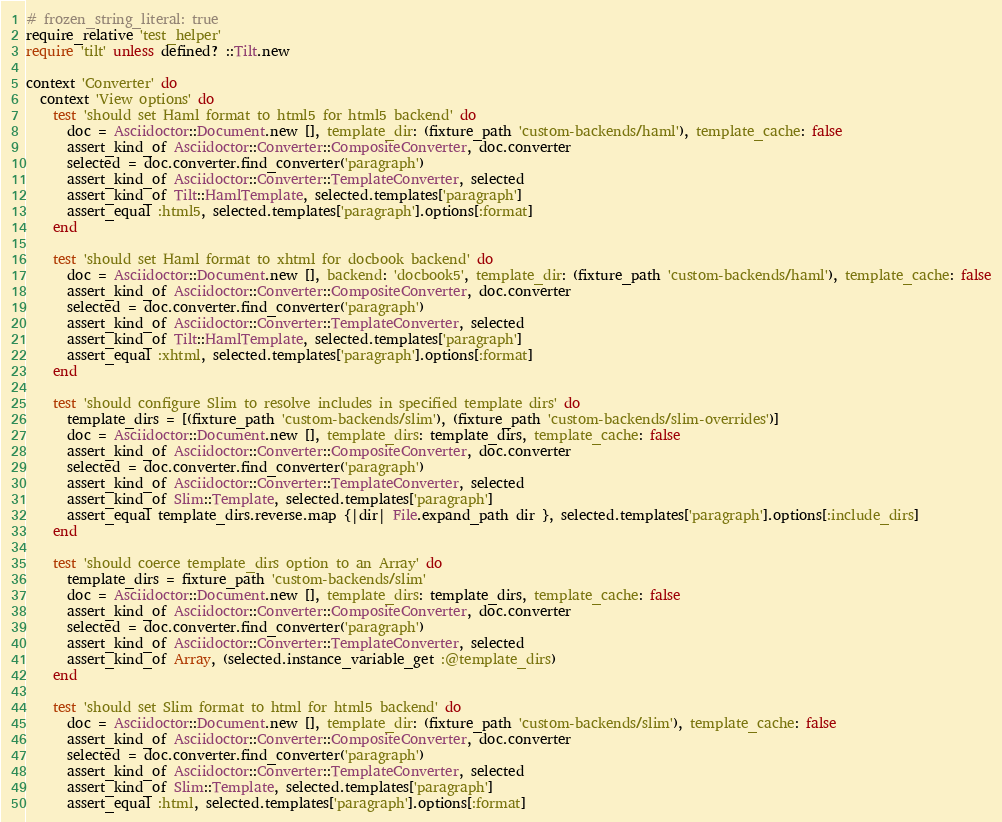Convert code to text. <code><loc_0><loc_0><loc_500><loc_500><_Ruby_># frozen_string_literal: true
require_relative 'test_helper'
require 'tilt' unless defined? ::Tilt.new

context 'Converter' do
  context 'View options' do
    test 'should set Haml format to html5 for html5 backend' do
      doc = Asciidoctor::Document.new [], template_dir: (fixture_path 'custom-backends/haml'), template_cache: false
      assert_kind_of Asciidoctor::Converter::CompositeConverter, doc.converter
      selected = doc.converter.find_converter('paragraph')
      assert_kind_of Asciidoctor::Converter::TemplateConverter, selected
      assert_kind_of Tilt::HamlTemplate, selected.templates['paragraph']
      assert_equal :html5, selected.templates['paragraph'].options[:format]
    end

    test 'should set Haml format to xhtml for docbook backend' do
      doc = Asciidoctor::Document.new [], backend: 'docbook5', template_dir: (fixture_path 'custom-backends/haml'), template_cache: false
      assert_kind_of Asciidoctor::Converter::CompositeConverter, doc.converter
      selected = doc.converter.find_converter('paragraph')
      assert_kind_of Asciidoctor::Converter::TemplateConverter, selected
      assert_kind_of Tilt::HamlTemplate, selected.templates['paragraph']
      assert_equal :xhtml, selected.templates['paragraph'].options[:format]
    end

    test 'should configure Slim to resolve includes in specified template dirs' do
      template_dirs = [(fixture_path 'custom-backends/slim'), (fixture_path 'custom-backends/slim-overrides')]
      doc = Asciidoctor::Document.new [], template_dirs: template_dirs, template_cache: false
      assert_kind_of Asciidoctor::Converter::CompositeConverter, doc.converter
      selected = doc.converter.find_converter('paragraph')
      assert_kind_of Asciidoctor::Converter::TemplateConverter, selected
      assert_kind_of Slim::Template, selected.templates['paragraph']
      assert_equal template_dirs.reverse.map {|dir| File.expand_path dir }, selected.templates['paragraph'].options[:include_dirs]
    end

    test 'should coerce template_dirs option to an Array' do
      template_dirs = fixture_path 'custom-backends/slim'
      doc = Asciidoctor::Document.new [], template_dirs: template_dirs, template_cache: false
      assert_kind_of Asciidoctor::Converter::CompositeConverter, doc.converter
      selected = doc.converter.find_converter('paragraph')
      assert_kind_of Asciidoctor::Converter::TemplateConverter, selected
      assert_kind_of Array, (selected.instance_variable_get :@template_dirs)
    end

    test 'should set Slim format to html for html5 backend' do
      doc = Asciidoctor::Document.new [], template_dir: (fixture_path 'custom-backends/slim'), template_cache: false
      assert_kind_of Asciidoctor::Converter::CompositeConverter, doc.converter
      selected = doc.converter.find_converter('paragraph')
      assert_kind_of Asciidoctor::Converter::TemplateConverter, selected
      assert_kind_of Slim::Template, selected.templates['paragraph']
      assert_equal :html, selected.templates['paragraph'].options[:format]</code> 